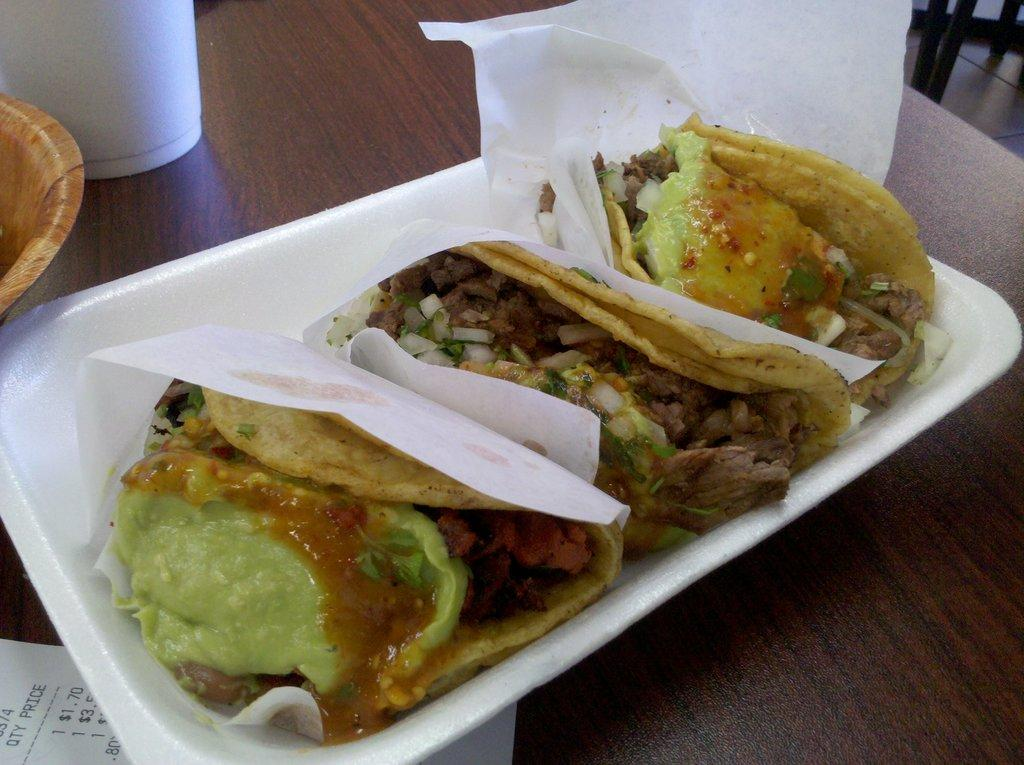What is present on the table in the image? There are objects on the table. Can you describe the tray on the table? There is a tray on the table. What can be found inside the tray? There are food items in the tray. What type of silk fabric is draped over the food items in the tray? There is no silk fabric present in the image; the food items are directly in the tray. 